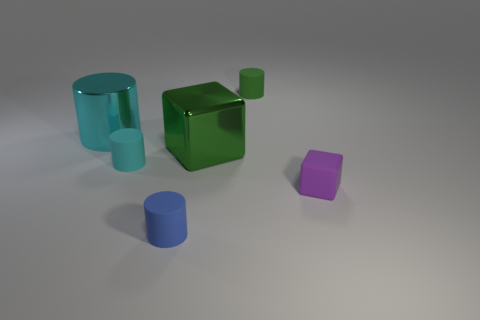Subtract all small green cylinders. How many cylinders are left? 3 Subtract all blue cubes. Subtract all blue cylinders. How many cubes are left? 2 Add 2 small green rubber cylinders. How many objects exist? 8 Subtract all cyan cylinders. How many cylinders are left? 2 Subtract all cylinders. How many objects are left? 2 Subtract 1 blocks. How many blocks are left? 1 Subtract all green balls. How many red cylinders are left? 0 Subtract all tiny blue rubber things. Subtract all tiny blue matte cylinders. How many objects are left? 4 Add 4 blue objects. How many blue objects are left? 5 Add 5 purple blocks. How many purple blocks exist? 6 